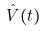Convert formula to latex. <formula><loc_0><loc_0><loc_500><loc_500>\hat { V } ( t )</formula> 